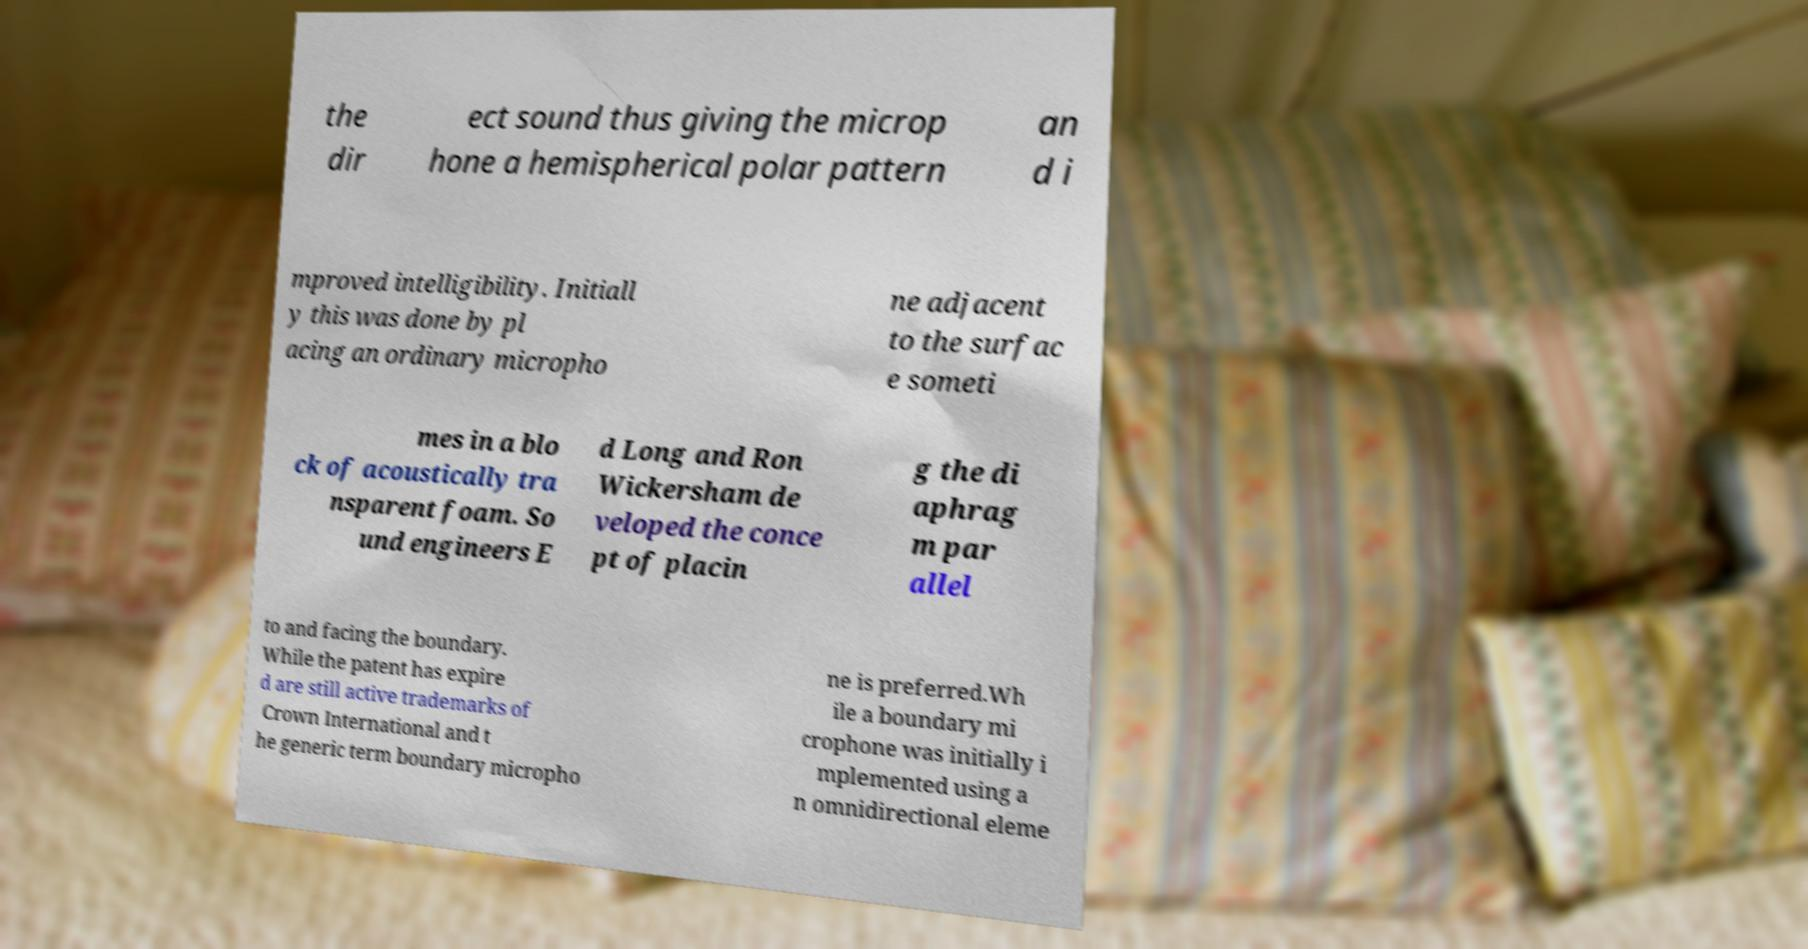What messages or text are displayed in this image? I need them in a readable, typed format. the dir ect sound thus giving the microp hone a hemispherical polar pattern an d i mproved intelligibility. Initiall y this was done by pl acing an ordinary micropho ne adjacent to the surfac e someti mes in a blo ck of acoustically tra nsparent foam. So und engineers E d Long and Ron Wickersham de veloped the conce pt of placin g the di aphrag m par allel to and facing the boundary. While the patent has expire d are still active trademarks of Crown International and t he generic term boundary micropho ne is preferred.Wh ile a boundary mi crophone was initially i mplemented using a n omnidirectional eleme 